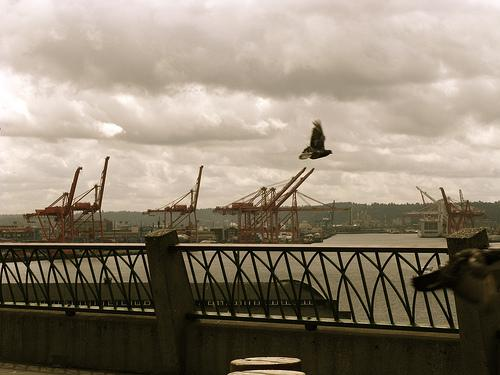Question: what is in the water?
Choices:
A. Sailboats.
B. Surfers.
C. Water skiers.
D. Oil rigs.
Answer with the letter. Answer: D Question: how does the weather look?
Choices:
A. Cloudy.
B. Sunny.
C. Snowy.
D. Rainy.
Answer with the letter. Answer: A Question: where was picture taken from?
Choices:
A. From the pier.
B. From an airplane.
C. From a boat.
D. From the shore.
Answer with the letter. Answer: A Question: who is in the picture?
Choices:
A. Two girls.
B. An old woman.
C. An old man.
D. Nobody.
Answer with the letter. Answer: D Question: what does sky look like?
Choices:
A. Blue.
B. Sunny.
C. Like it may rain.
D. Grey.
Answer with the letter. Answer: C Question: where is picture taken at?
Choices:
A. The beach.
B. The mountains.
C. A ski slope.
D. A pier by the water.
Answer with the letter. Answer: D 